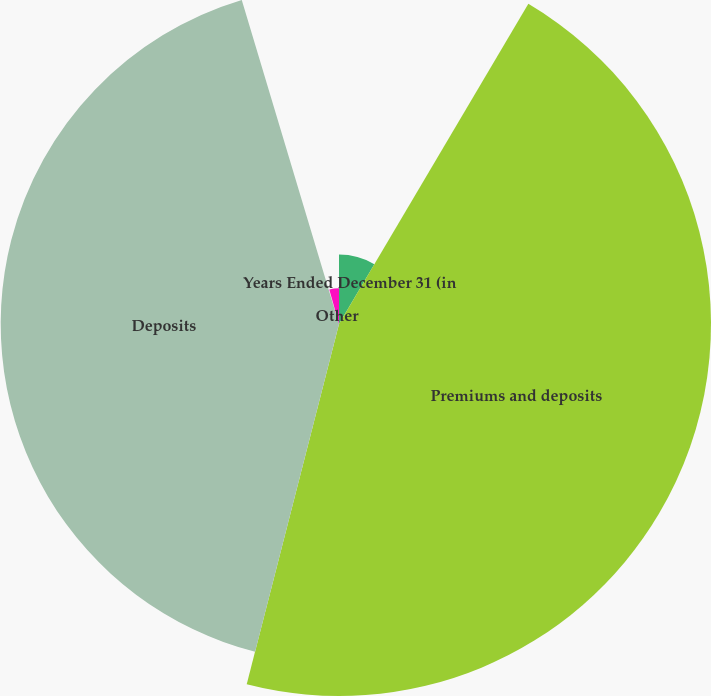Convert chart. <chart><loc_0><loc_0><loc_500><loc_500><pie_chart><fcel>Years Ended December 31 (in<fcel>Premiums and deposits<fcel>Deposits<fcel>Other<fcel>Premiums<nl><fcel>8.5%<fcel>45.49%<fcel>41.37%<fcel>0.26%<fcel>4.38%<nl></chart> 